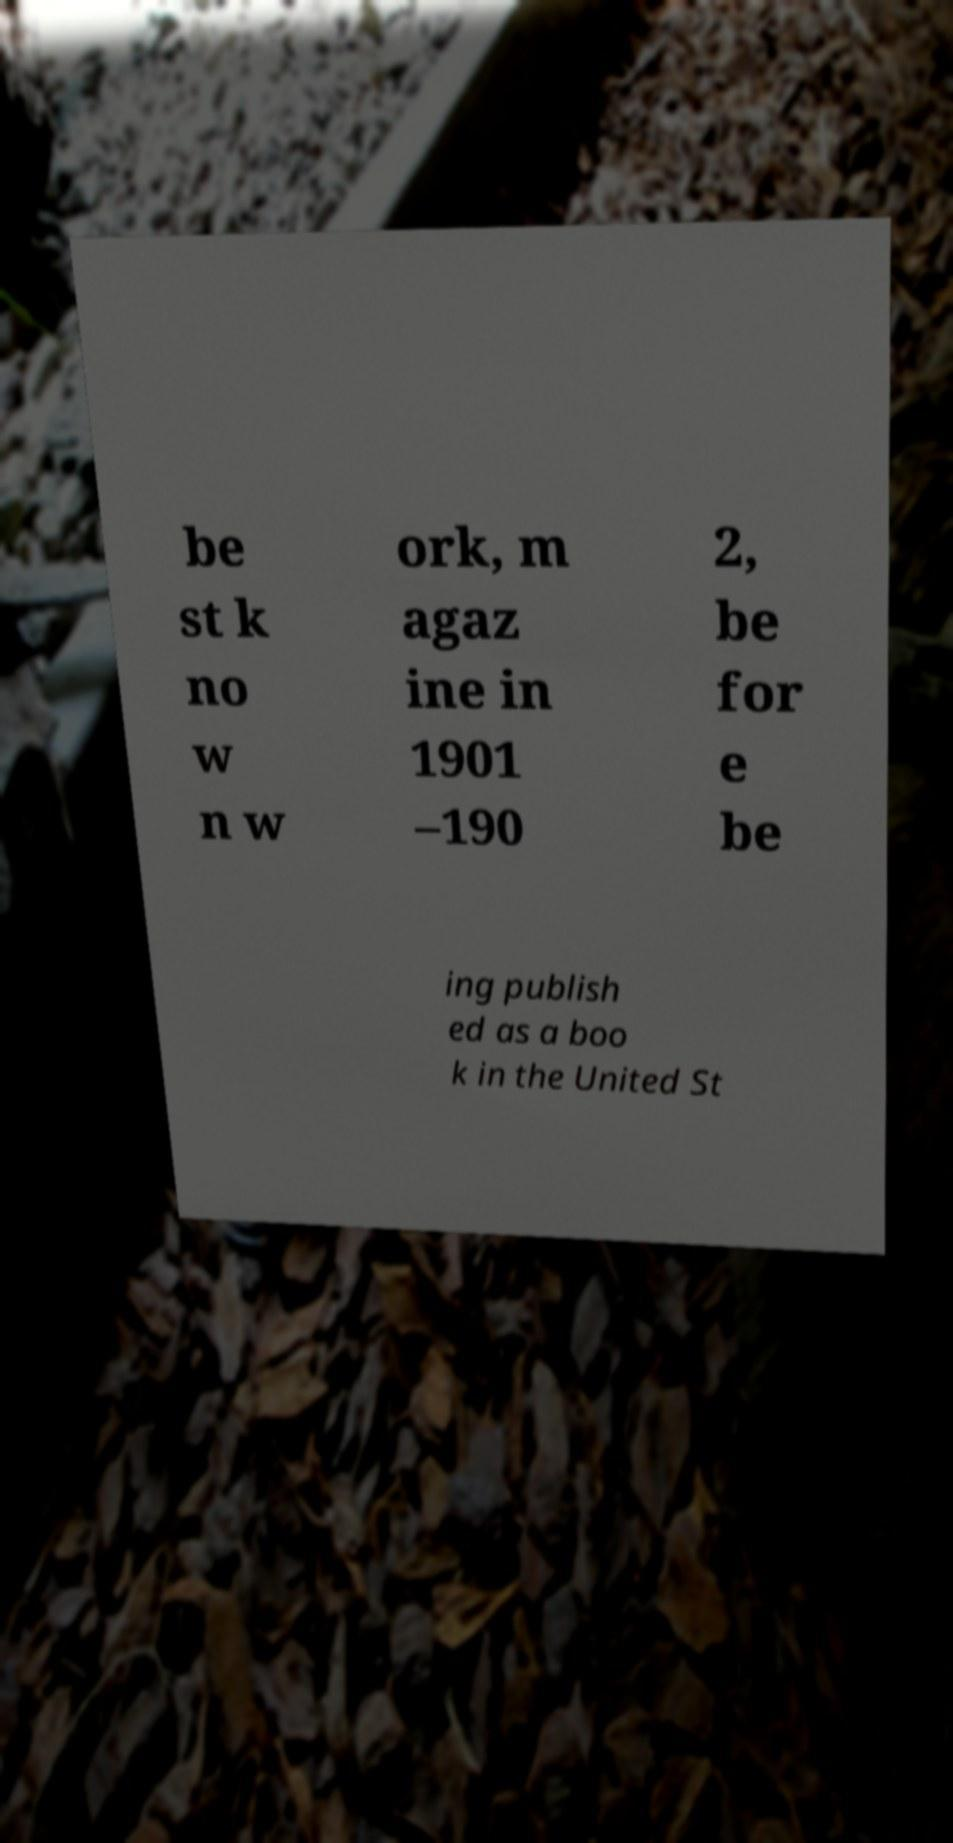There's text embedded in this image that I need extracted. Can you transcribe it verbatim? be st k no w n w ork, m agaz ine in 1901 –190 2, be for e be ing publish ed as a boo k in the United St 